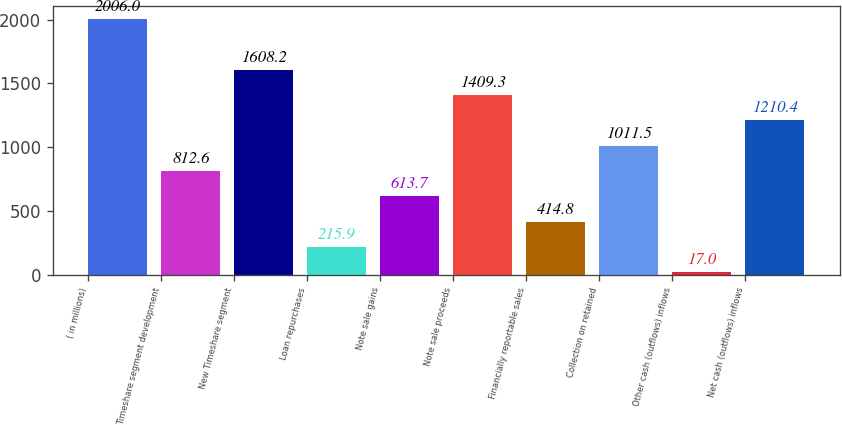Convert chart to OTSL. <chart><loc_0><loc_0><loc_500><loc_500><bar_chart><fcel>( in millions)<fcel>Timeshare segment development<fcel>New Timeshare segment<fcel>Loan repurchases<fcel>Note sale gains<fcel>Note sale proceeds<fcel>Financially reportable sales<fcel>Collection on retained<fcel>Other cash (outflows) inflows<fcel>Net cash (outflows) inflows<nl><fcel>2006<fcel>812.6<fcel>1608.2<fcel>215.9<fcel>613.7<fcel>1409.3<fcel>414.8<fcel>1011.5<fcel>17<fcel>1210.4<nl></chart> 